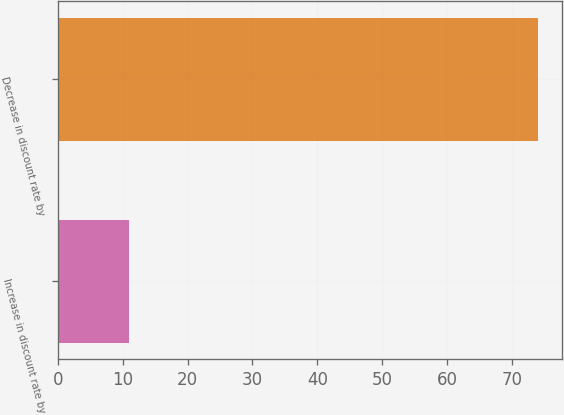Convert chart to OTSL. <chart><loc_0><loc_0><loc_500><loc_500><bar_chart><fcel>Increase in discount rate by<fcel>Decrease in discount rate by<nl><fcel>11<fcel>74<nl></chart> 